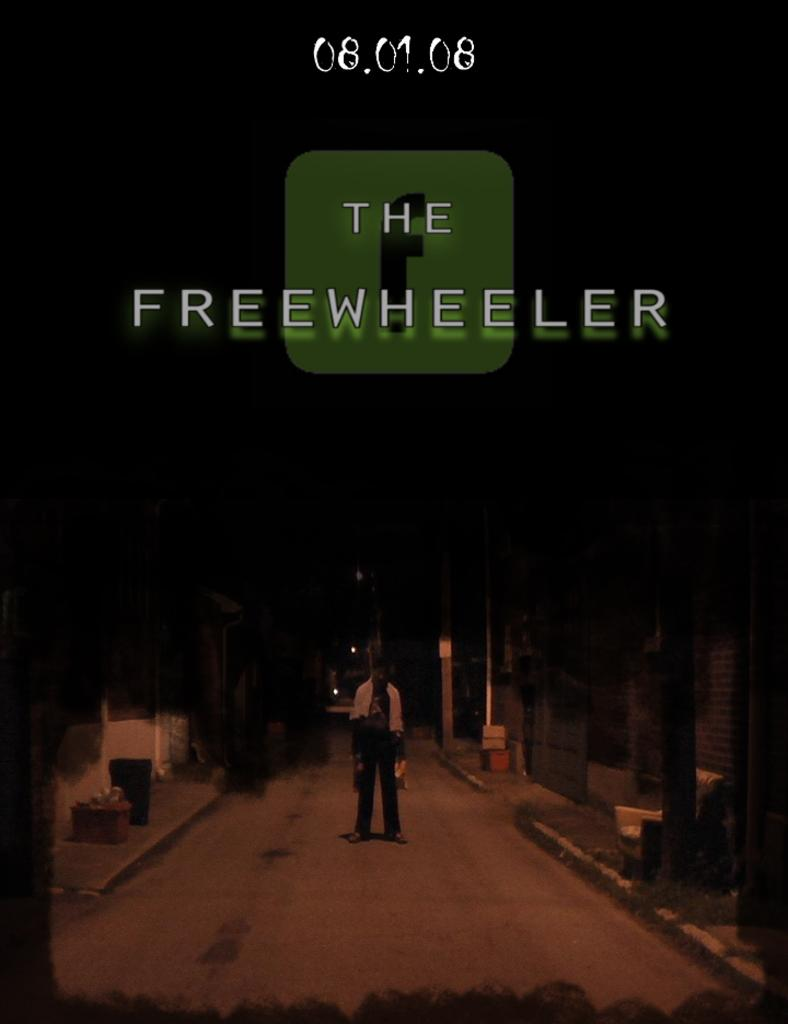<image>
Render a clear and concise summary of the photo. The Freewheeler was an event held on August 1, 2008. 